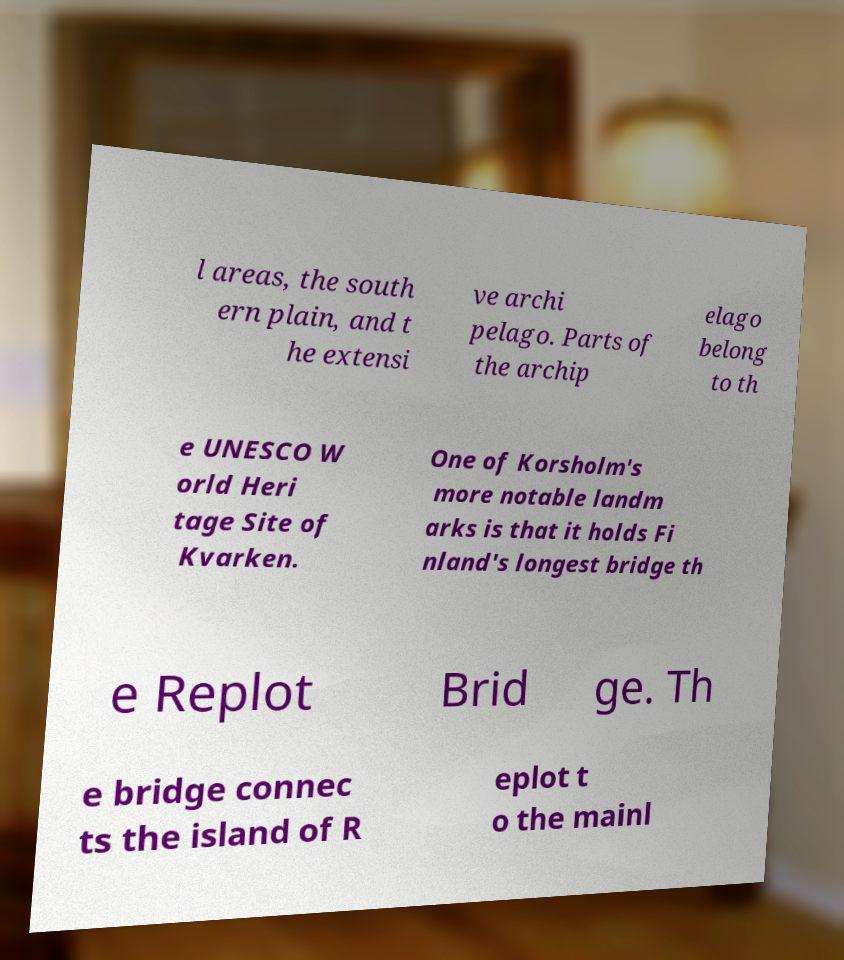Please identify and transcribe the text found in this image. l areas, the south ern plain, and t he extensi ve archi pelago. Parts of the archip elago belong to th e UNESCO W orld Heri tage Site of Kvarken. One of Korsholm's more notable landm arks is that it holds Fi nland's longest bridge th e Replot Brid ge. Th e bridge connec ts the island of R eplot t o the mainl 